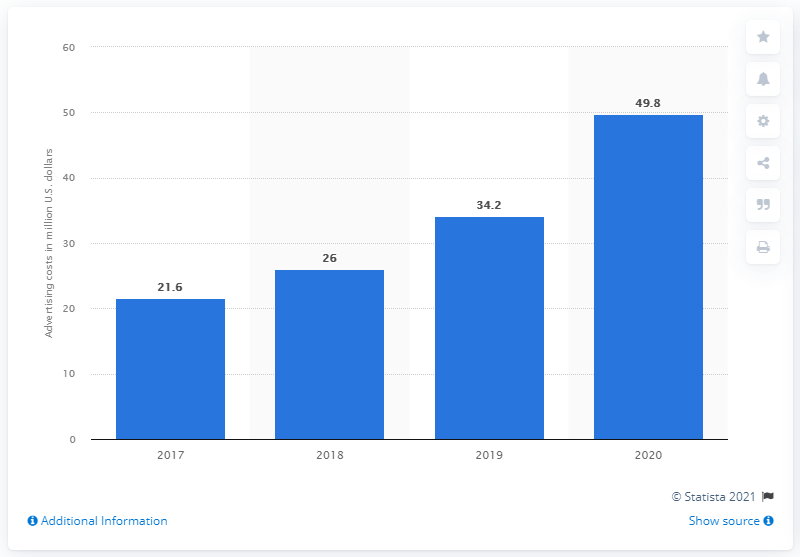Mention a couple of crucial points in this snapshot. Spectrum Brands' advertising costs in 2020 were approximately $49.8 million. Spectrum Brands spent $34.2 million a year earlier. 